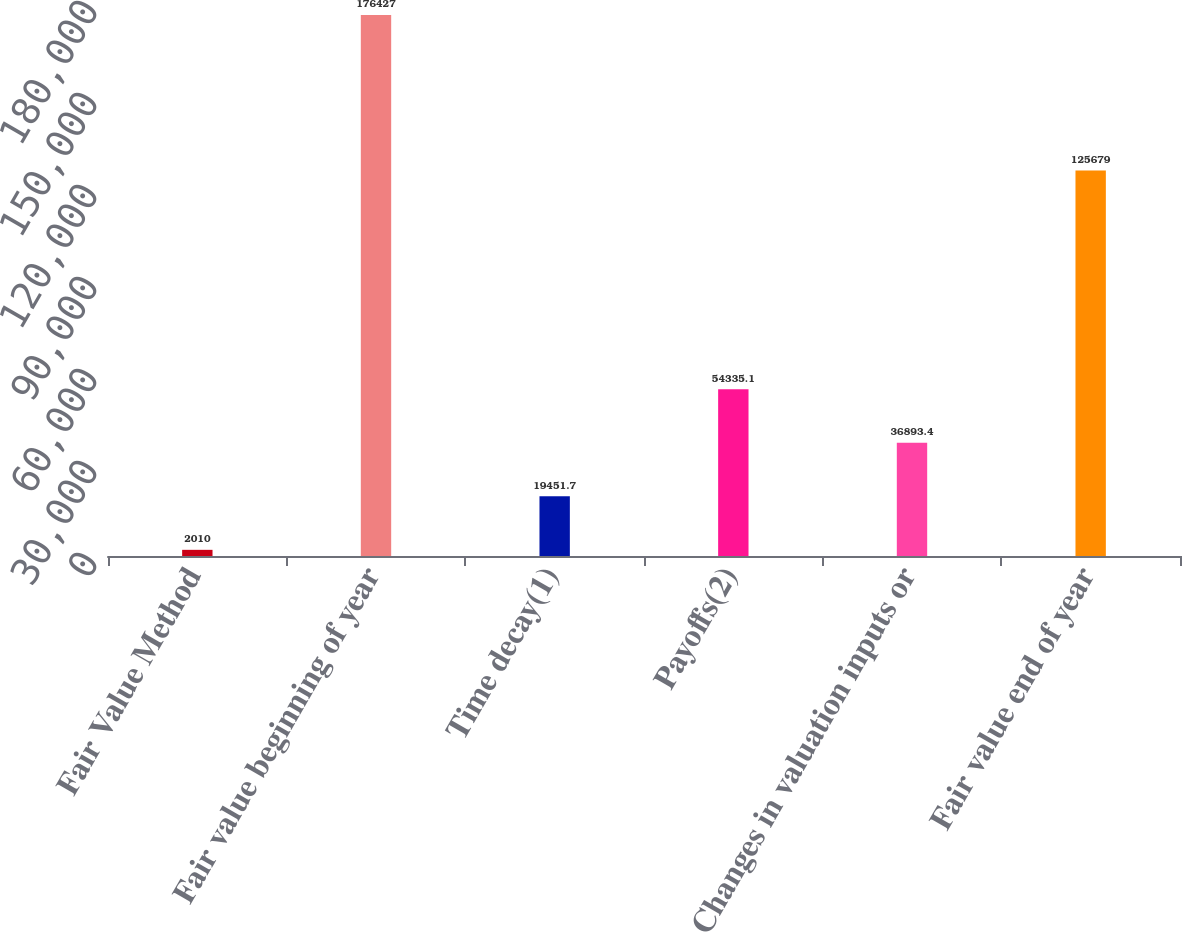Convert chart to OTSL. <chart><loc_0><loc_0><loc_500><loc_500><bar_chart><fcel>Fair Value Method<fcel>Fair value beginning of year<fcel>Time decay(1)<fcel>Payoffs(2)<fcel>Changes in valuation inputs or<fcel>Fair value end of year<nl><fcel>2010<fcel>176427<fcel>19451.7<fcel>54335.1<fcel>36893.4<fcel>125679<nl></chart> 